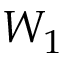<formula> <loc_0><loc_0><loc_500><loc_500>W _ { 1 }</formula> 